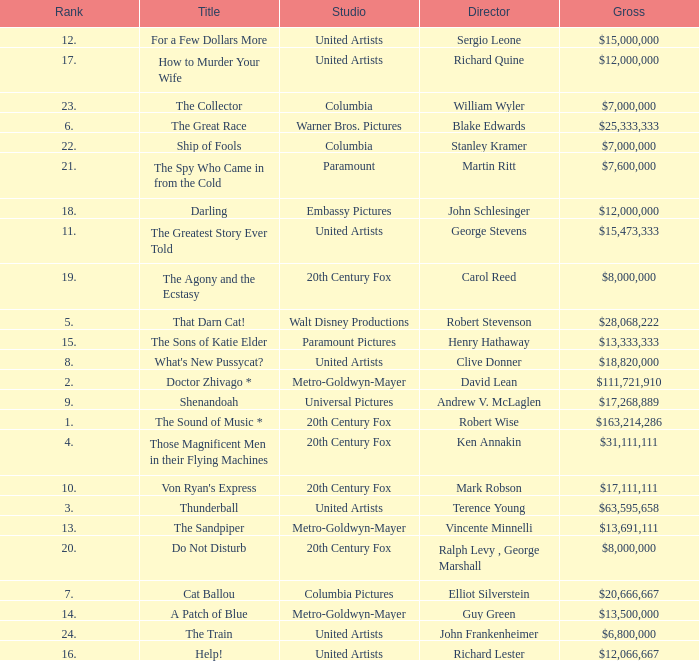What is the highest Rank, when Director is "Henry Hathaway"? 15.0. 